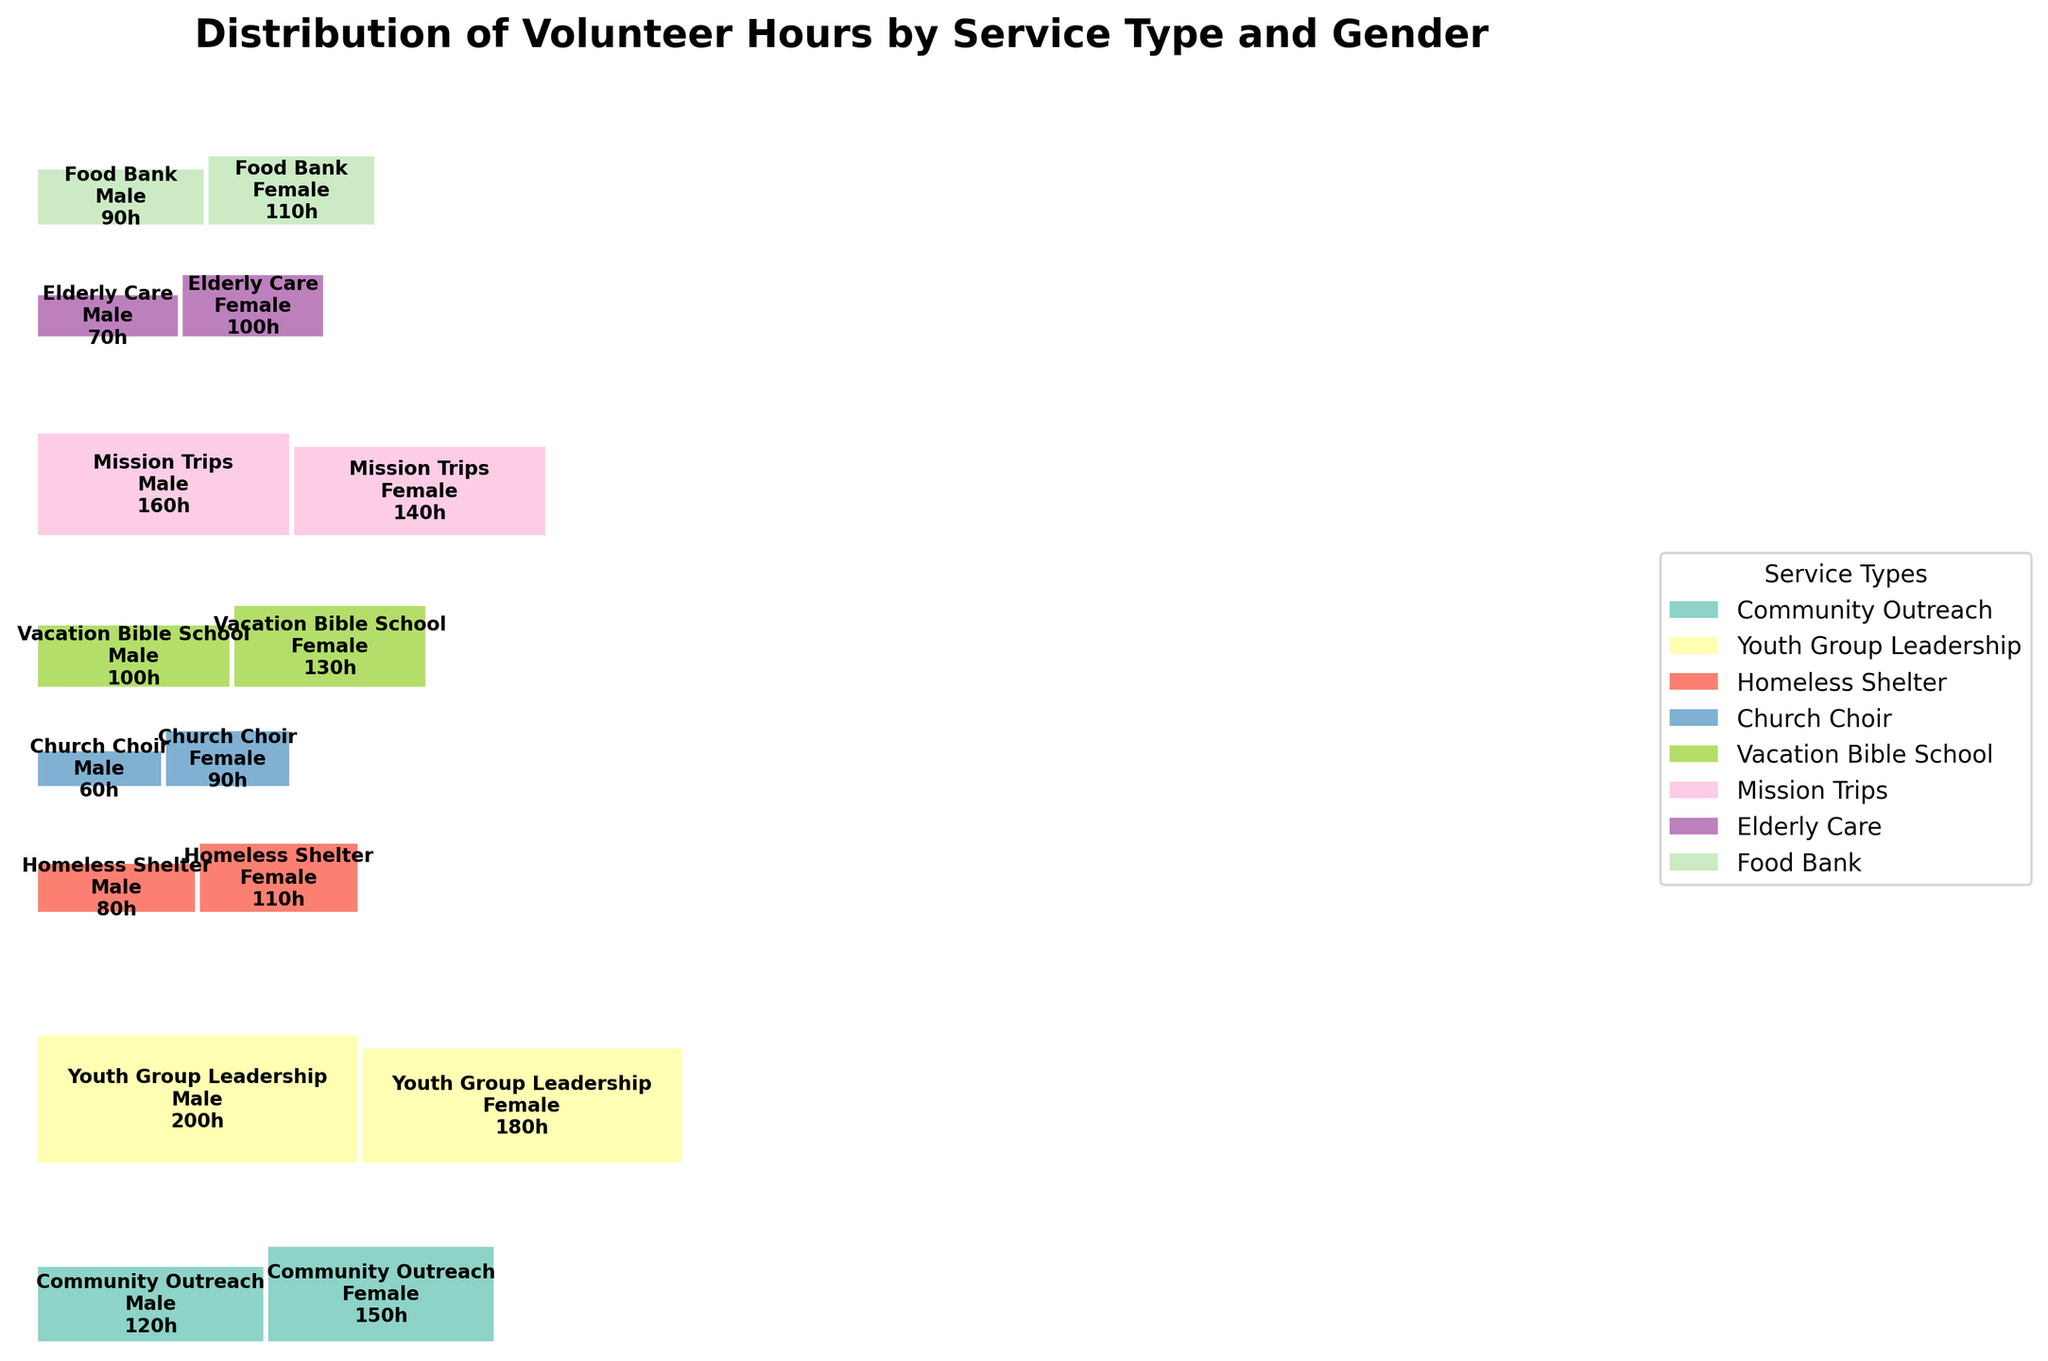Which service type did males contribute the most hours to? The bar representing "Youth Group Leadership" for males is the tallest bar among all service types for males.
Answer: Youth Group Leadership Which service type has the smallest total hours contributed by both genders? By observing the overall height and width of the bars, "Church Choir" appears to have the smallest total area, indicating the smallest total hours.
Answer: Church Choir How many hours did females contribute to "Mission Trips"? The area corresponding to females and "Mission Trips" is labeled with the specific value of 140 hours.
Answer: 140 What is the total number of hours contributed to "Vacation Bible School" by both genders? Add the hours contributed by males and females in "Vacation Bible School" (100 + 130).
Answer: 230 Which gender contributed more hours to "Homeless Shelter"? Compare the areas for males and females in "Homeless Shelter." The female section is larger.
Answer: Female What service type had an equal distribution of hours between genders? By comparing areas, "Food Bank" shows both genders with nearly equal-sized sections.
Answer: Food Bank How many hours did males contribute to "Community Outreach"? The area corresponding to males and "Community Outreach" is labeled with the specific value of 120 hours.
Answer: 120 What service type did females contribute the fewest hours to? The service type section with the smallest area for females is "Church Choir."
Answer: Church Choir Compare the total hours of "Youth Group Leadership" and "Elderly Care." Which one is higher? Calculate the total hours for both. "Youth Group Leadership" has 200 (male) + 180 (female) = 380. "Elderly Care" has 70 (male) + 100 (female) = 170.
Answer: Youth Group Leadership 